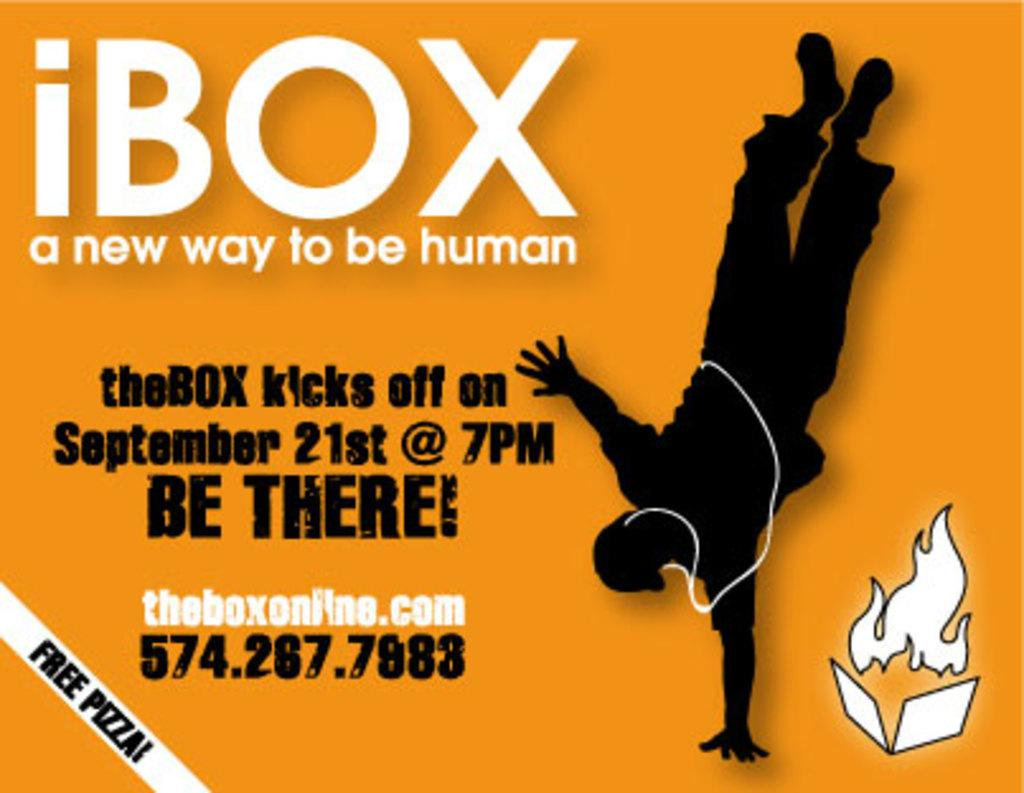<image>
Write a terse but informative summary of the picture. yellow background that says iBOX a new way to be human 